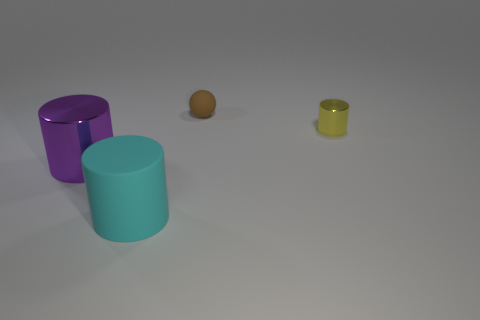What materials do the objects in the image seem to be made of? The cylinders and the ball appear to be made of a kind of polished metal, given their reflective properties and the slight highlights and shadows that define their shapes. 